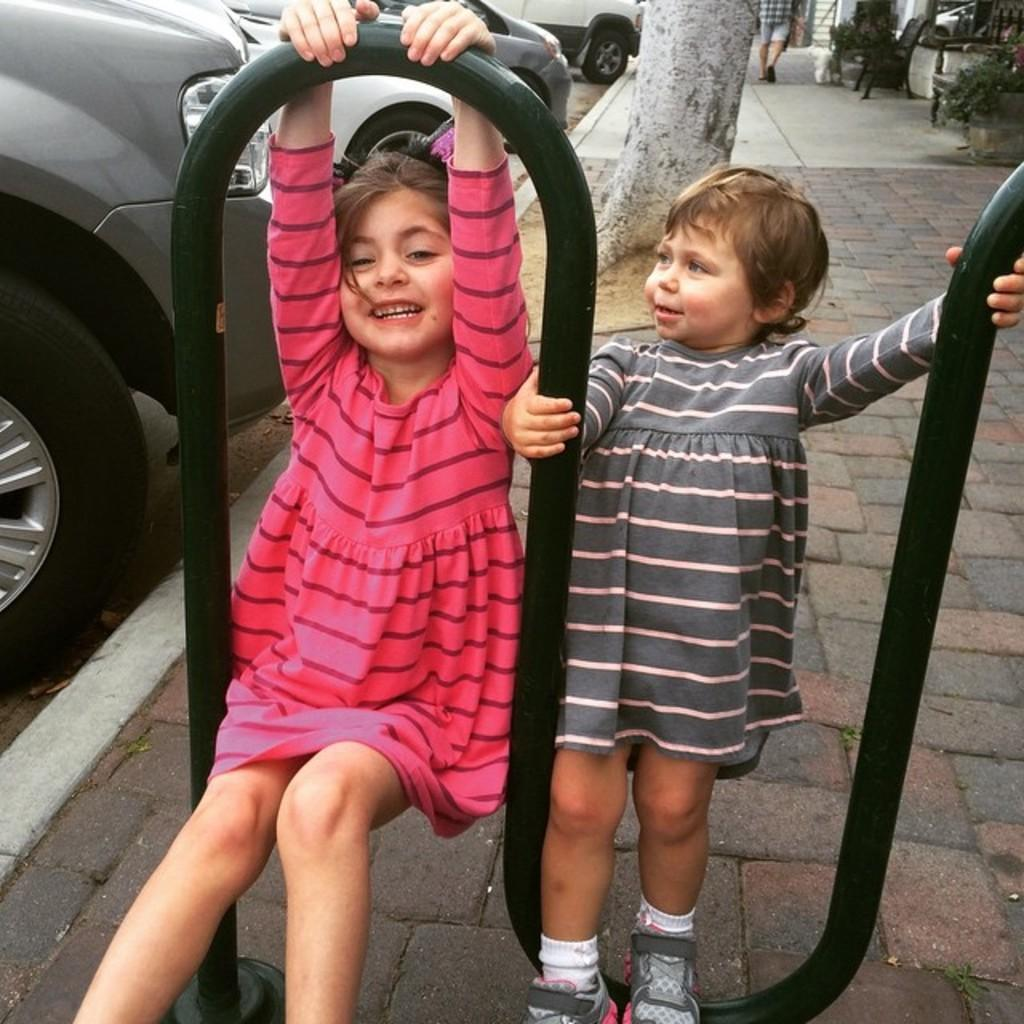How many kids are in the image? There are two kids in the image. What else can be seen in the image besides the kids? There are cars in the image. Can you describe the background of the image? There is a person walking in the background of the image. Where is the kitty playing with a frog in the image? There is no kitty or frog present in the image. What type of hat is the person wearing in the background of the image? There is no hat mentioned or visible in the image. 